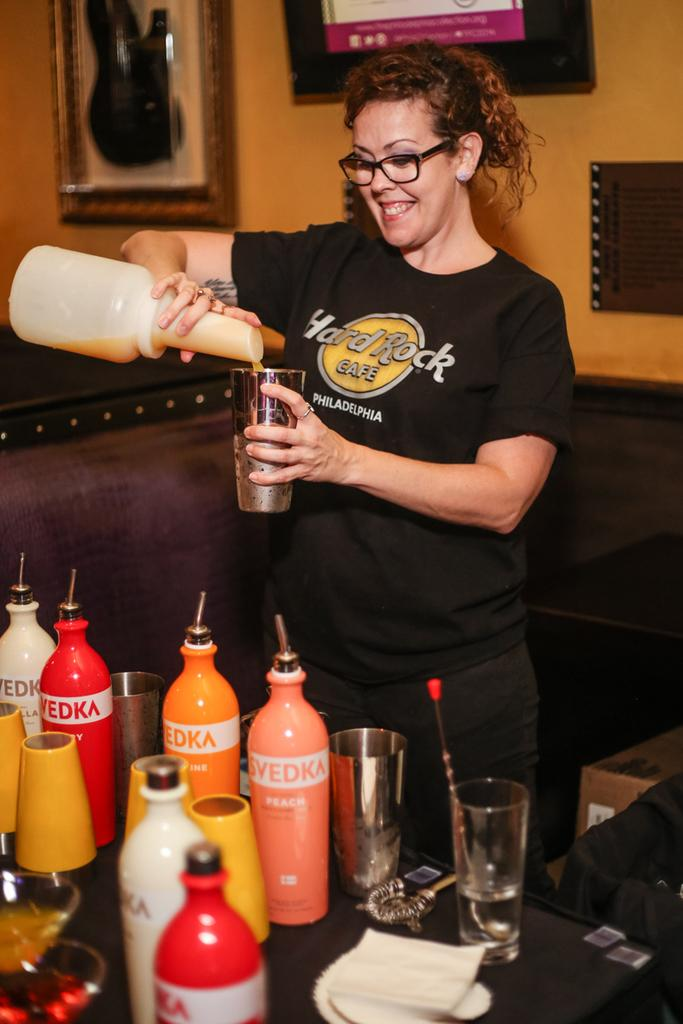<image>
Offer a succinct explanation of the picture presented. A bottle of Svedka peach sits in front of a woman making drinks. 